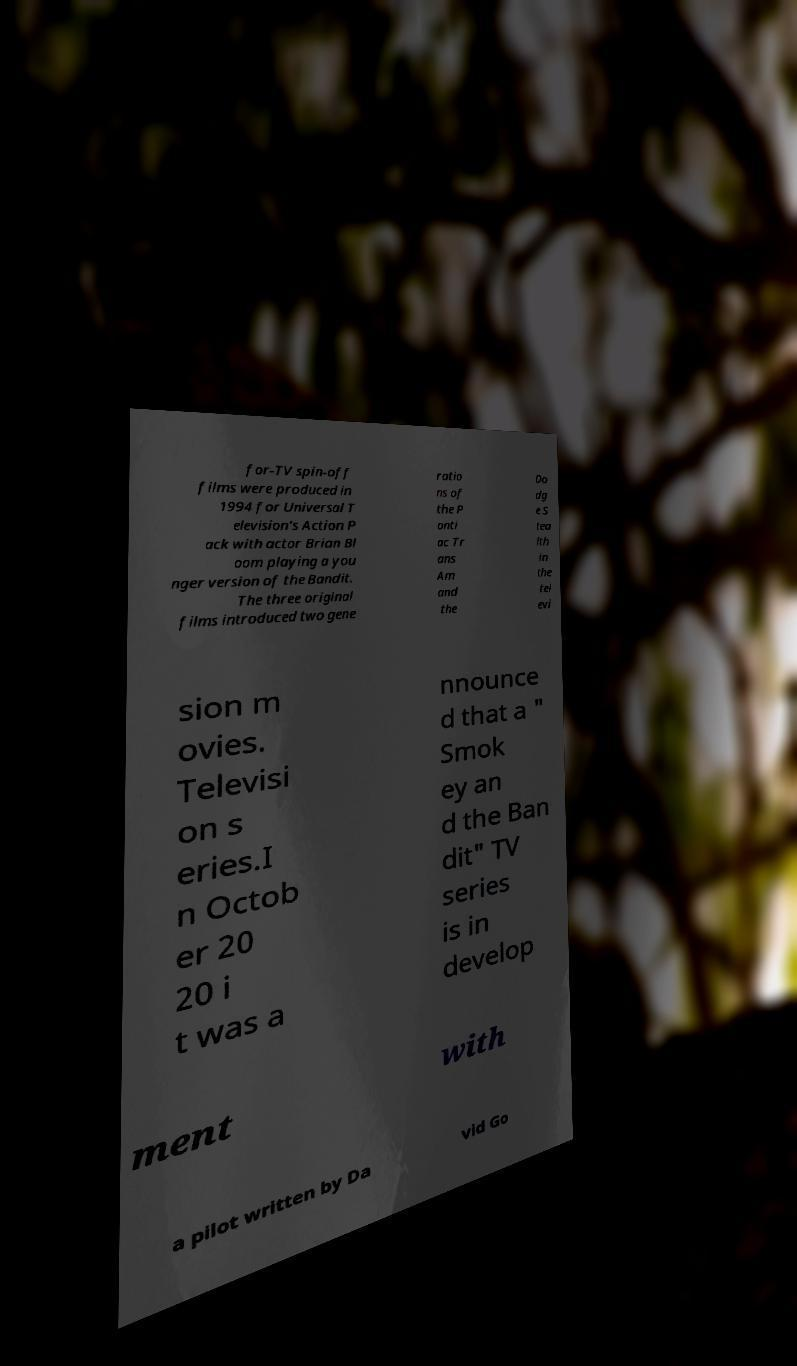There's text embedded in this image that I need extracted. Can you transcribe it verbatim? for-TV spin-off films were produced in 1994 for Universal T elevision's Action P ack with actor Brian Bl oom playing a you nger version of the Bandit. The three original films introduced two gene ratio ns of the P onti ac Tr ans Am and the Do dg e S tea lth in the tel evi sion m ovies. Televisi on s eries.I n Octob er 20 20 i t was a nnounce d that a " Smok ey an d the Ban dit" TV series is in develop ment with a pilot written by Da vid Go 